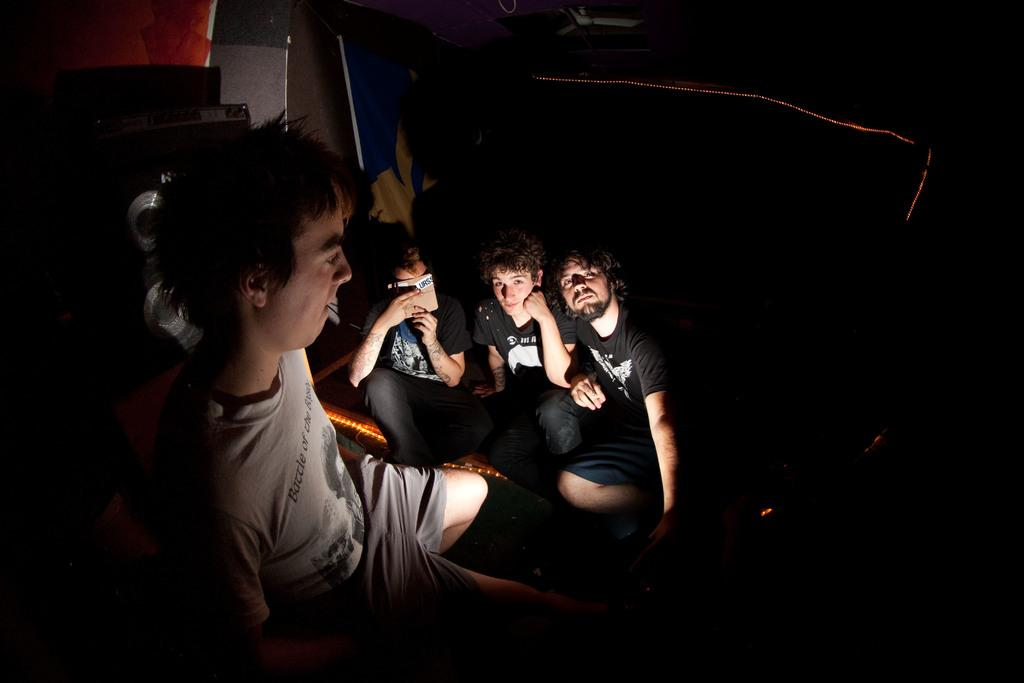Who or what can be seen in the image? There are people in the image. What is located behind the people? There are objects behind the people. What can be seen in the background of the image? There are lights visible in the background of the image. What type of neck can be seen on the people in the image? There is no specific mention of necks in the image, so it cannot be determined what type of neck the people have. 